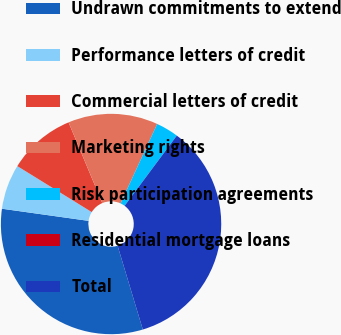Convert chart. <chart><loc_0><loc_0><loc_500><loc_500><pie_chart><fcel>Undrawn commitments to extend<fcel>Performance letters of credit<fcel>Commercial letters of credit<fcel>Marketing rights<fcel>Risk participation agreements<fcel>Residential mortgage loans<fcel>Total<nl><fcel>31.87%<fcel>6.59%<fcel>9.89%<fcel>13.18%<fcel>3.3%<fcel>0.0%<fcel>35.17%<nl></chart> 